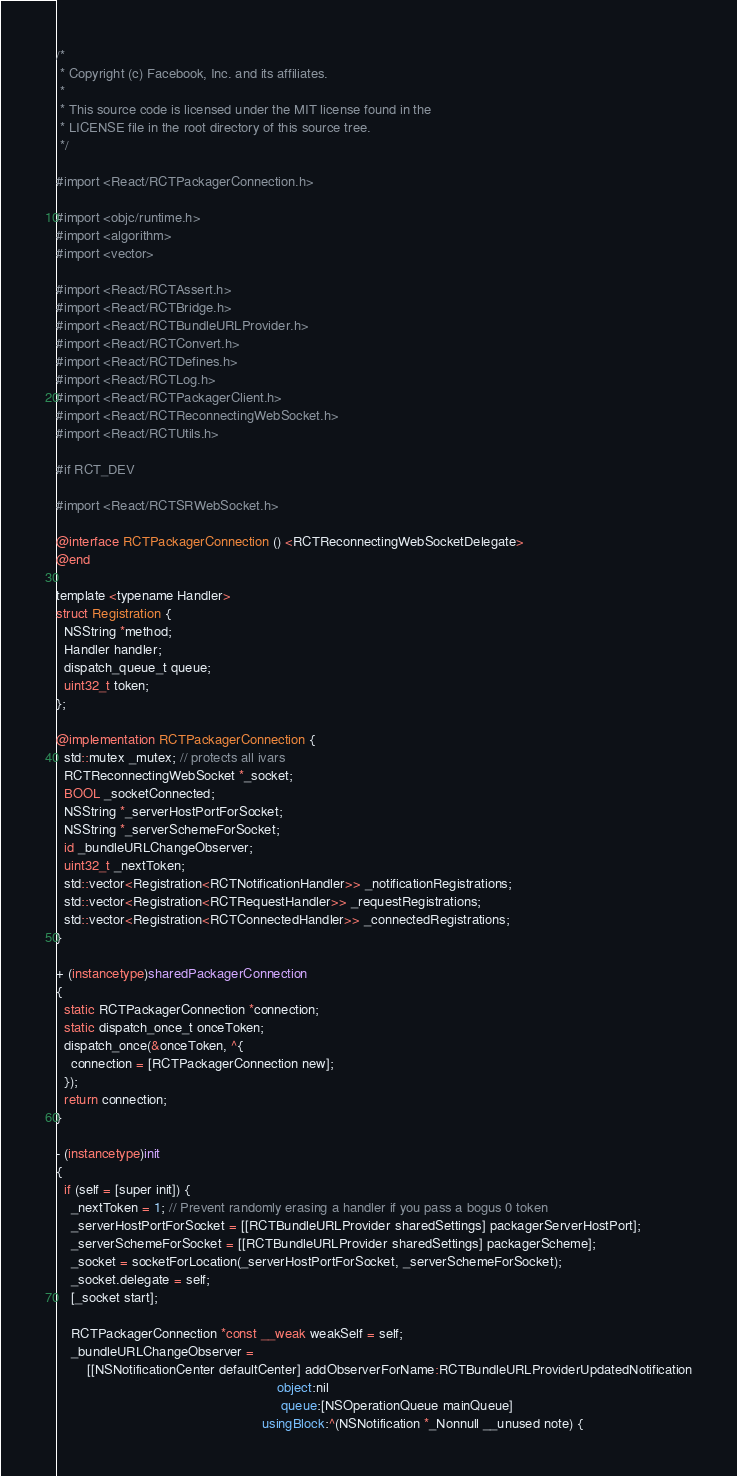<code> <loc_0><loc_0><loc_500><loc_500><_ObjectiveC_>/*
 * Copyright (c) Facebook, Inc. and its affiliates.
 *
 * This source code is licensed under the MIT license found in the
 * LICENSE file in the root directory of this source tree.
 */

#import <React/RCTPackagerConnection.h>

#import <objc/runtime.h>
#import <algorithm>
#import <vector>

#import <React/RCTAssert.h>
#import <React/RCTBridge.h>
#import <React/RCTBundleURLProvider.h>
#import <React/RCTConvert.h>
#import <React/RCTDefines.h>
#import <React/RCTLog.h>
#import <React/RCTPackagerClient.h>
#import <React/RCTReconnectingWebSocket.h>
#import <React/RCTUtils.h>

#if RCT_DEV

#import <React/RCTSRWebSocket.h>

@interface RCTPackagerConnection () <RCTReconnectingWebSocketDelegate>
@end

template <typename Handler>
struct Registration {
  NSString *method;
  Handler handler;
  dispatch_queue_t queue;
  uint32_t token;
};

@implementation RCTPackagerConnection {
  std::mutex _mutex; // protects all ivars
  RCTReconnectingWebSocket *_socket;
  BOOL _socketConnected;
  NSString *_serverHostPortForSocket;
  NSString *_serverSchemeForSocket;
  id _bundleURLChangeObserver;
  uint32_t _nextToken;
  std::vector<Registration<RCTNotificationHandler>> _notificationRegistrations;
  std::vector<Registration<RCTRequestHandler>> _requestRegistrations;
  std::vector<Registration<RCTConnectedHandler>> _connectedRegistrations;
}

+ (instancetype)sharedPackagerConnection
{
  static RCTPackagerConnection *connection;
  static dispatch_once_t onceToken;
  dispatch_once(&onceToken, ^{
    connection = [RCTPackagerConnection new];
  });
  return connection;
}

- (instancetype)init
{
  if (self = [super init]) {
    _nextToken = 1; // Prevent randomly erasing a handler if you pass a bogus 0 token
    _serverHostPortForSocket = [[RCTBundleURLProvider sharedSettings] packagerServerHostPort];
    _serverSchemeForSocket = [[RCTBundleURLProvider sharedSettings] packagerScheme];
    _socket = socketForLocation(_serverHostPortForSocket, _serverSchemeForSocket);
    _socket.delegate = self;
    [_socket start];

    RCTPackagerConnection *const __weak weakSelf = self;
    _bundleURLChangeObserver =
        [[NSNotificationCenter defaultCenter] addObserverForName:RCTBundleURLProviderUpdatedNotification
                                                          object:nil
                                                           queue:[NSOperationQueue mainQueue]
                                                      usingBlock:^(NSNotification *_Nonnull __unused note) {</code> 